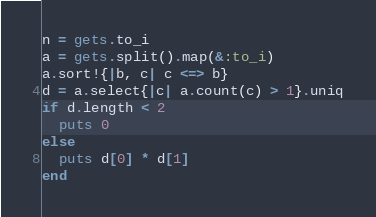<code> <loc_0><loc_0><loc_500><loc_500><_Ruby_>n = gets.to_i
a = gets.split().map(&:to_i)
a.sort!{|b, c| c <=> b}
d = a.select{|c| a.count(c) > 1}.uniq
if d.length < 2
  puts 0
else
  puts d[0] * d[1]
end
</code> 